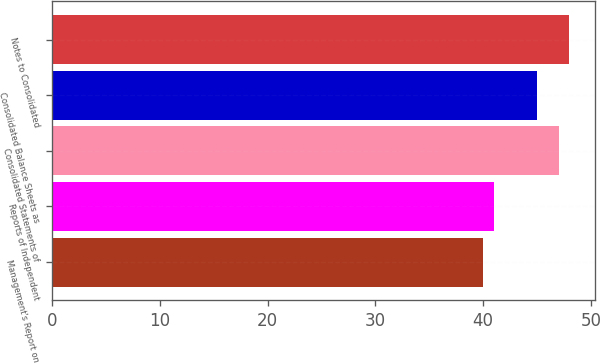<chart> <loc_0><loc_0><loc_500><loc_500><bar_chart><fcel>Management's Report on<fcel>Reports of Independent<fcel>Consolidated Statements of<fcel>Consolidated Balance Sheets as<fcel>Notes to Consolidated<nl><fcel>40<fcel>41<fcel>47<fcel>45<fcel>48<nl></chart> 